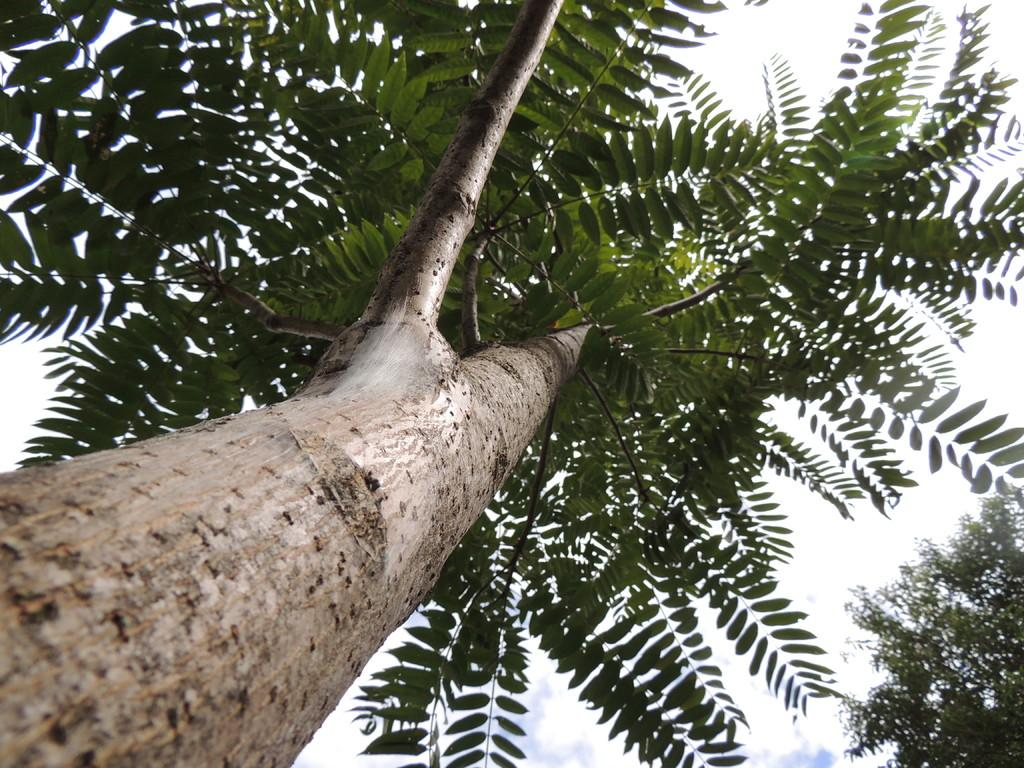What is the main subject in the center of the image? There is a big tree in the center of the image. Are there any other trees visible in the image? Yes, there is another tree in the bottom right side of the image. What type of sweater is the dinosaur wearing in the image? There are no dinosaurs or sweaters present in the image. 